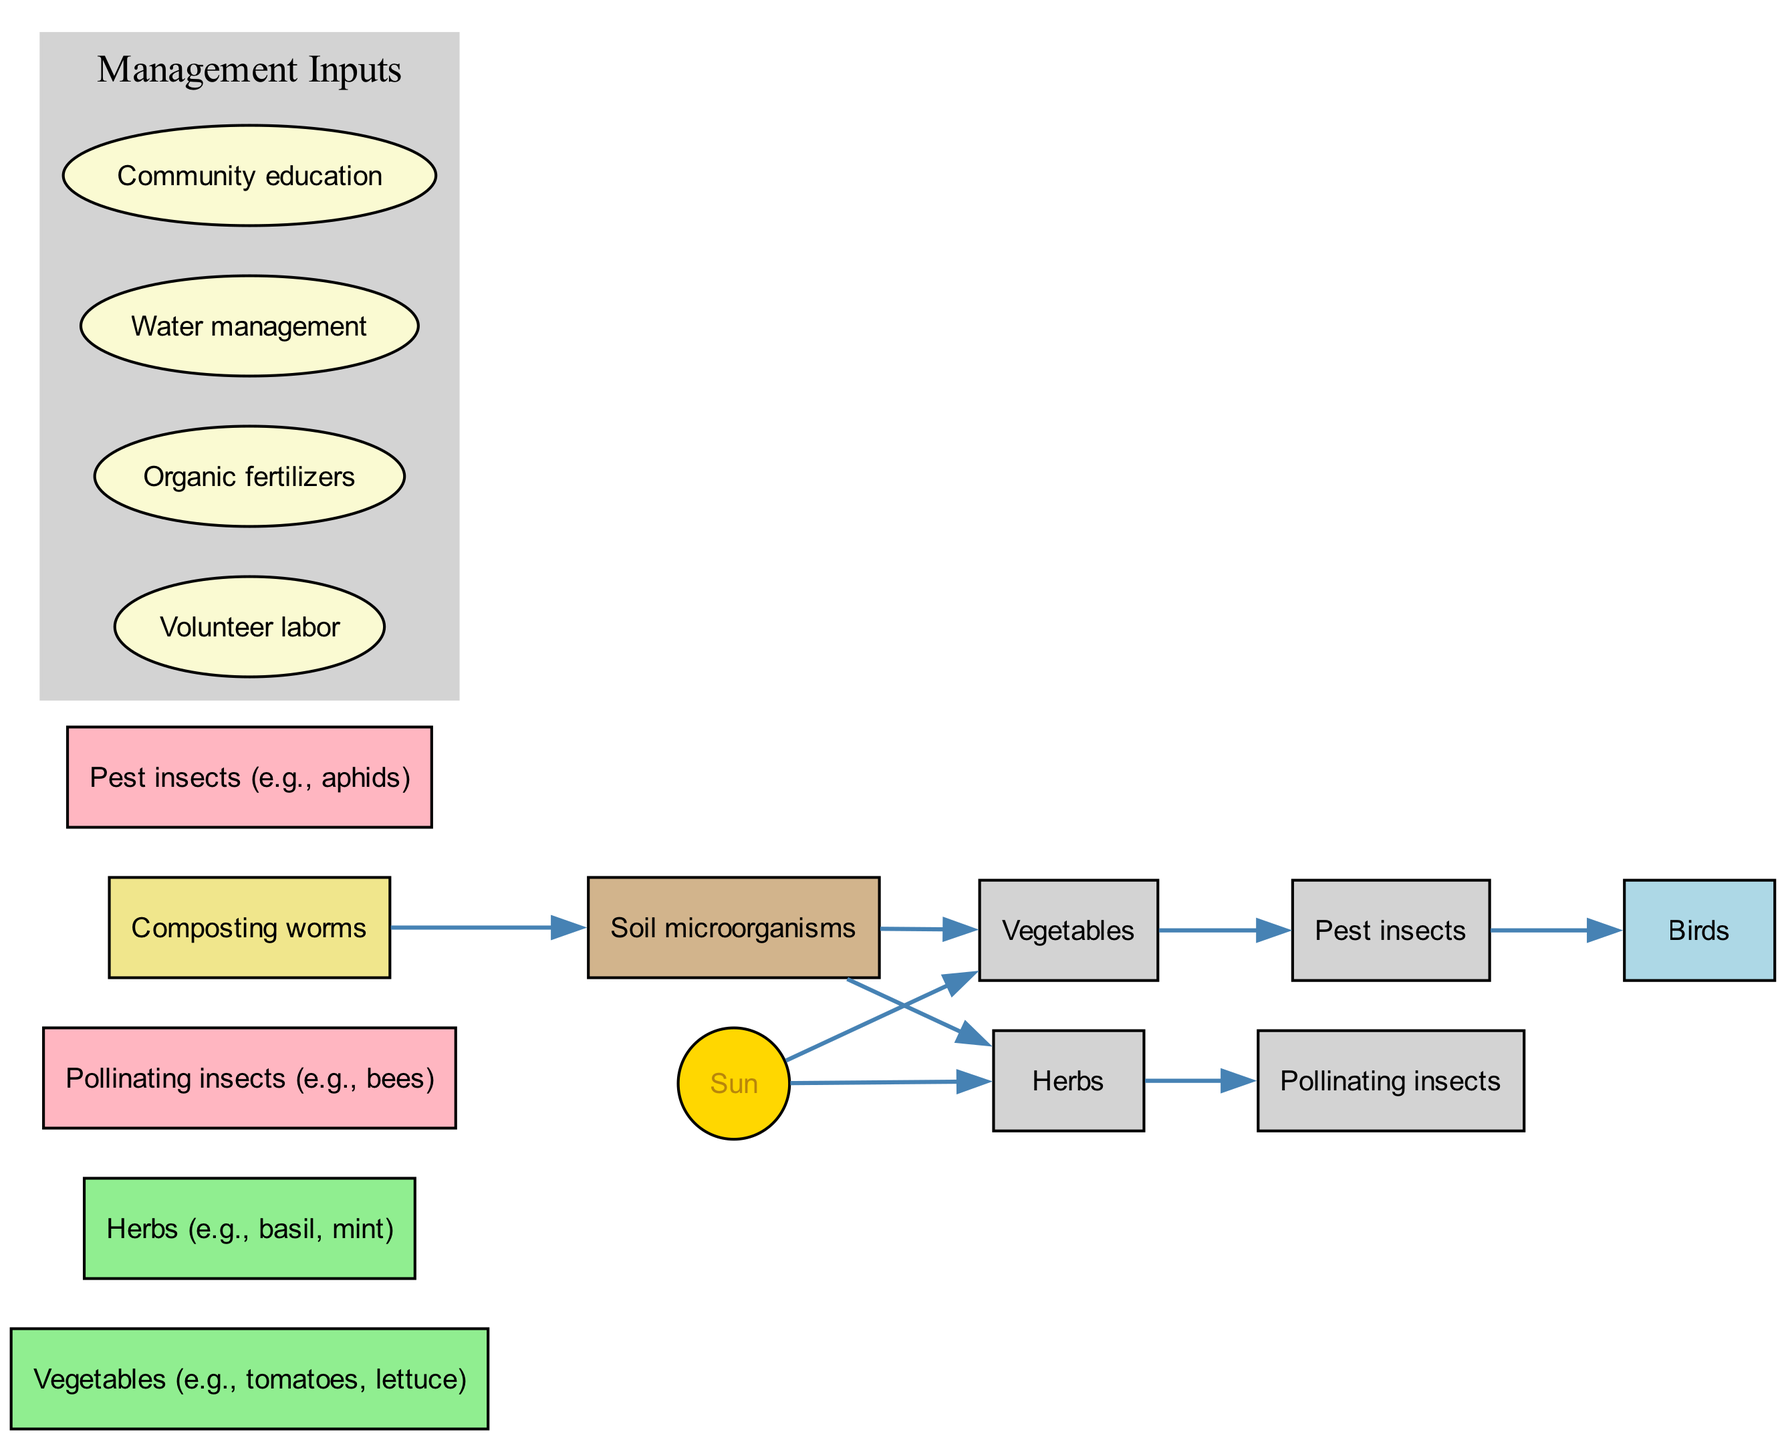How many organisms are represented in the diagram? The diagram lists several organisms involved in the food chain. By counting the entries in the 'organisms' list, we find there are seven different organisms represented.
Answer: 7 What do pollinating insects eat? The diagram shows that pollinating insects, represented by the node "Pollinating insects," are directly connected by an edge from "Herbs." This indicates that they feed on herbs.
Answer: Herbs Which organism is at the top of the food chain? The food chain can be deduced by looking at the energy flow direction. "Birds" are at the end of the flow line where they consume "Pest insects," indicating they occupy the top position in this chain.
Answer: Birds What is the role of composting worms? The diagram indicates a flow from "Composting worms" to "Soil microorganisms," which suggests that composting worms' role is to contribute nutrients to the soil through their interactions with microorganisms.
Answer: Soil microorganisms How many management inputs are shown in the diagram? The management inputs are clustered together in a distinct section labeled "Management Inputs." By counting the input nodes listed, there are four management inputs displayed in the diagram.
Answer: 4 Which organism is directly affected by soil microorganisms? From the diagram, there are two direct flows from "Soil microorganisms" to "Vegetables" and "Herbs," indicating that both vegetables and herbs are affected by soil microorganisms.
Answer: Vegetables, Herbs What type of diagram is this? The structure indicates a flow of energy through various organisms, showcasing relations between them in a community garden. Thus, this represents a food chain diagram, specifically in an ecological context.
Answer: Food chain What do vegetables rely on for energy? The diagram indicates a direct energy flow from "Sun" to "Vegetables," showing that vegetables rely on sunlight as their energy source for growth.
Answer: Sun Which organism indirectly supports pest insects? The diagram shows that "Vegetables" are consumed by "Pest insects," which means that any indirect support to pest insects comes from the "Vegetables" itself.
Answer: Vegetables 